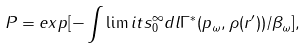Convert formula to latex. <formula><loc_0><loc_0><loc_500><loc_500>P = e x p [ - \int \lim i t s _ { 0 } ^ { \infty } d l \Gamma ^ { * } ( p _ { \omega } , \rho ( r ^ { \prime } ) ) / \beta _ { \omega } ] ,</formula> 